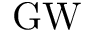Convert formula to latex. <formula><loc_0><loc_0><loc_500><loc_500>G W</formula> 